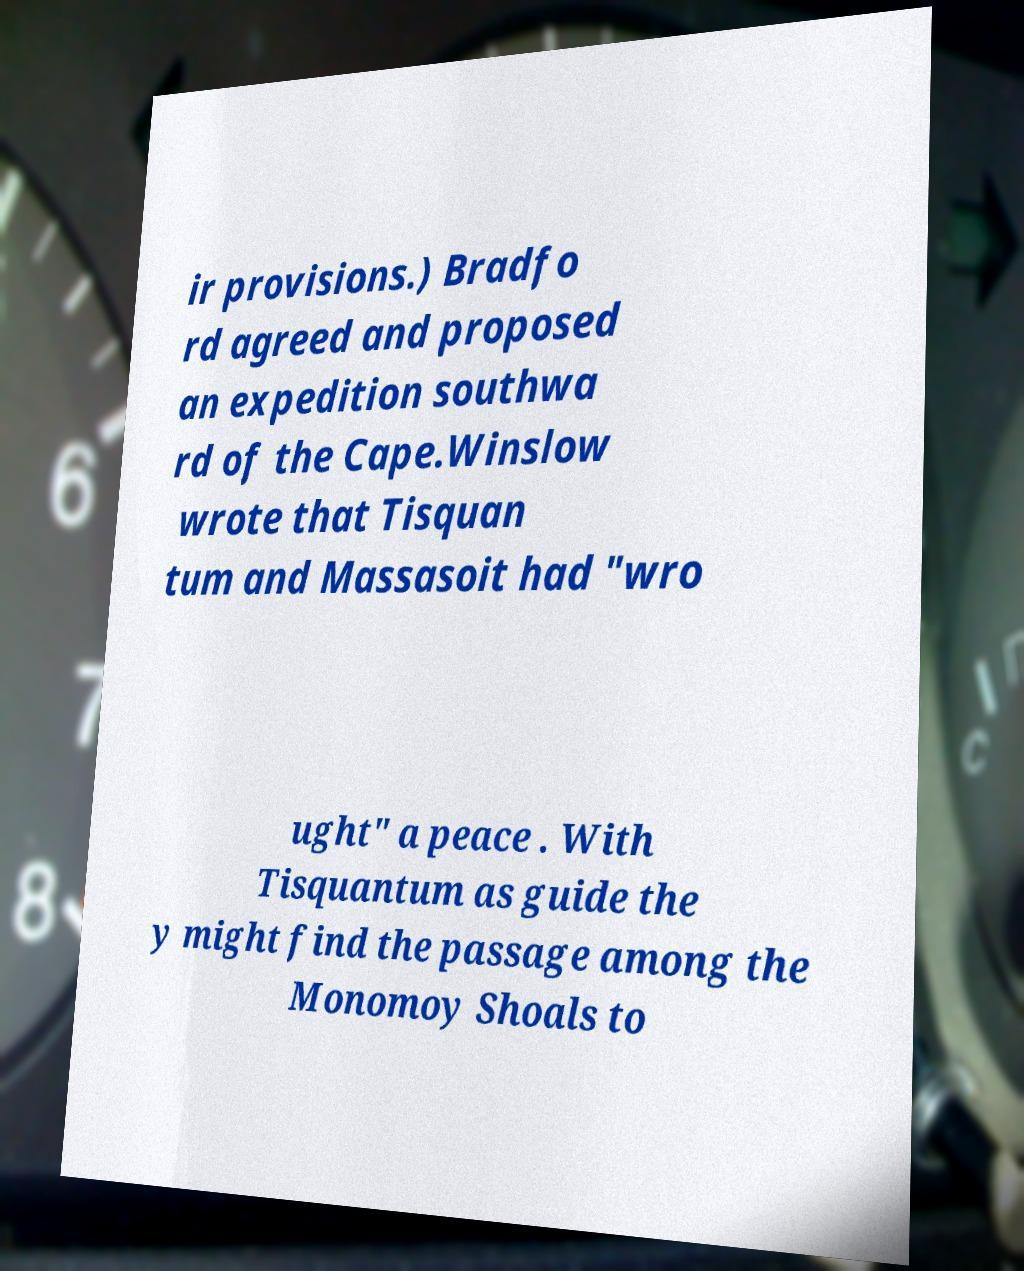What messages or text are displayed in this image? I need them in a readable, typed format. ir provisions.) Bradfo rd agreed and proposed an expedition southwa rd of the Cape.Winslow wrote that Tisquan tum and Massasoit had "wro ught" a peace . With Tisquantum as guide the y might find the passage among the Monomoy Shoals to 